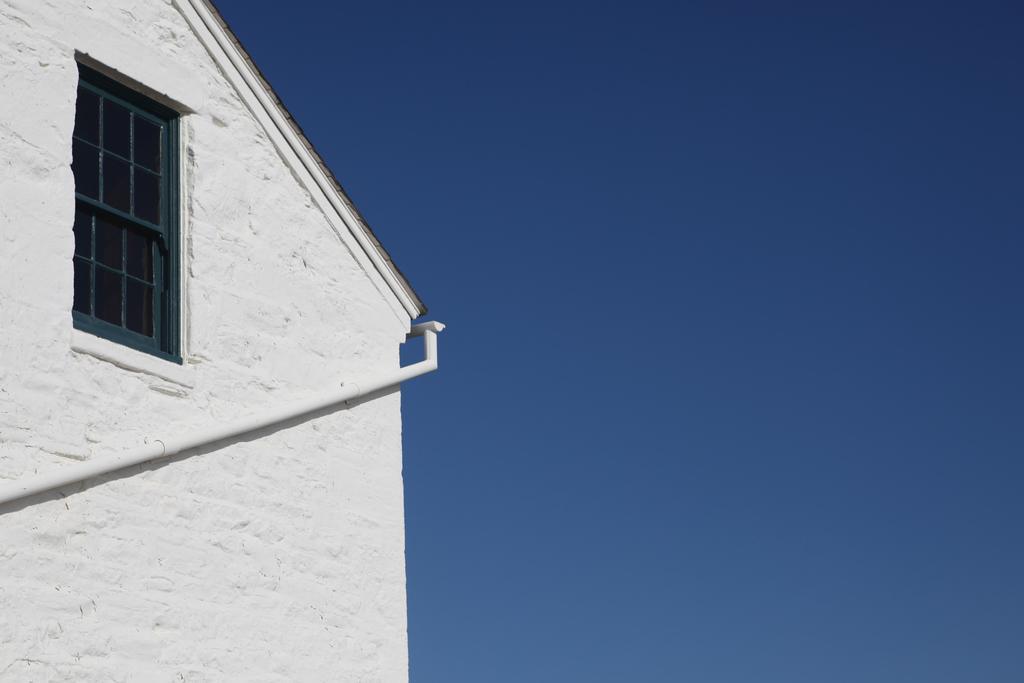Can you describe this image briefly? In this image image I can see a white colour building on the left side and on it I can see a white colour pipe. I can also see a window and on the right side I can see the sky. 